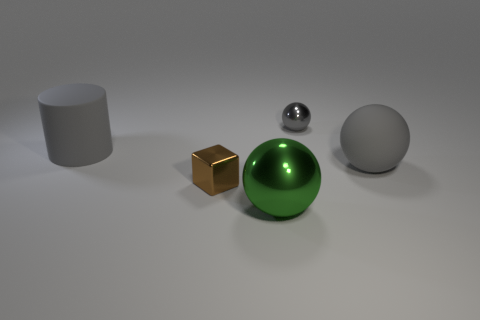Add 3 small yellow objects. How many objects exist? 8 Subtract all blocks. How many objects are left? 4 Subtract all big gray cylinders. Subtract all gray balls. How many objects are left? 2 Add 3 large objects. How many large objects are left? 6 Add 2 cubes. How many cubes exist? 3 Subtract 0 purple spheres. How many objects are left? 5 